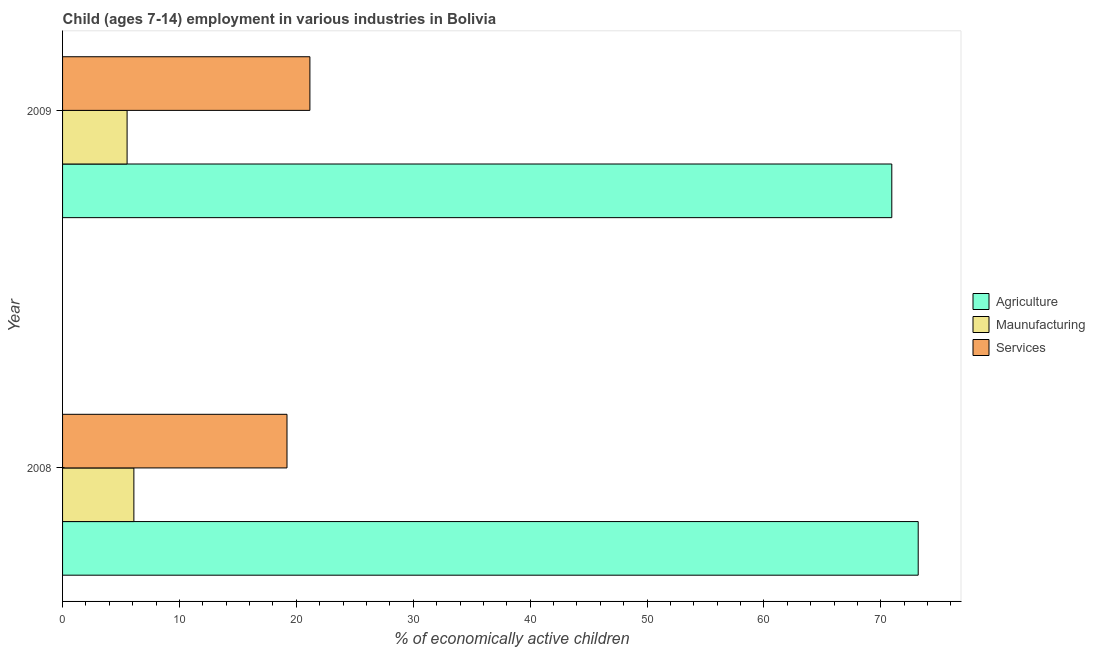How many different coloured bars are there?
Offer a very short reply. 3. How many groups of bars are there?
Your answer should be compact. 2. Are the number of bars per tick equal to the number of legend labels?
Keep it short and to the point. Yes. Are the number of bars on each tick of the Y-axis equal?
Ensure brevity in your answer.  Yes. How many bars are there on the 2nd tick from the top?
Offer a terse response. 3. What is the percentage of economically active children in agriculture in 2009?
Give a very brief answer. 70.94. Across all years, what is the maximum percentage of economically active children in manufacturing?
Keep it short and to the point. 6.1. Across all years, what is the minimum percentage of economically active children in services?
Make the answer very short. 19.2. In which year was the percentage of economically active children in agriculture maximum?
Make the answer very short. 2008. In which year was the percentage of economically active children in agriculture minimum?
Your answer should be very brief. 2009. What is the total percentage of economically active children in agriculture in the graph?
Ensure brevity in your answer.  144.14. What is the difference between the percentage of economically active children in agriculture in 2008 and that in 2009?
Offer a very short reply. 2.26. What is the difference between the percentage of economically active children in services in 2009 and the percentage of economically active children in manufacturing in 2008?
Provide a succinct answer. 15.06. What is the average percentage of economically active children in manufacturing per year?
Your answer should be very brief. 5.81. In the year 2008, what is the difference between the percentage of economically active children in agriculture and percentage of economically active children in services?
Your response must be concise. 54. In how many years, is the percentage of economically active children in manufacturing greater than 12 %?
Ensure brevity in your answer.  0. What is the ratio of the percentage of economically active children in services in 2008 to that in 2009?
Keep it short and to the point. 0.91. Is the difference between the percentage of economically active children in agriculture in 2008 and 2009 greater than the difference between the percentage of economically active children in services in 2008 and 2009?
Ensure brevity in your answer.  Yes. What does the 1st bar from the top in 2008 represents?
Provide a short and direct response. Services. What does the 2nd bar from the bottom in 2009 represents?
Provide a succinct answer. Maunufacturing. Is it the case that in every year, the sum of the percentage of economically active children in agriculture and percentage of economically active children in manufacturing is greater than the percentage of economically active children in services?
Your answer should be compact. Yes. How many bars are there?
Your answer should be compact. 6. Are all the bars in the graph horizontal?
Offer a terse response. Yes. How many years are there in the graph?
Your answer should be very brief. 2. Are the values on the major ticks of X-axis written in scientific E-notation?
Your response must be concise. No. Where does the legend appear in the graph?
Your response must be concise. Center right. What is the title of the graph?
Ensure brevity in your answer.  Child (ages 7-14) employment in various industries in Bolivia. What is the label or title of the X-axis?
Offer a very short reply. % of economically active children. What is the % of economically active children of Agriculture in 2008?
Offer a terse response. 73.2. What is the % of economically active children in Maunufacturing in 2008?
Ensure brevity in your answer.  6.1. What is the % of economically active children of Services in 2008?
Make the answer very short. 19.2. What is the % of economically active children in Agriculture in 2009?
Your answer should be compact. 70.94. What is the % of economically active children in Maunufacturing in 2009?
Offer a terse response. 5.52. What is the % of economically active children of Services in 2009?
Make the answer very short. 21.16. Across all years, what is the maximum % of economically active children in Agriculture?
Your response must be concise. 73.2. Across all years, what is the maximum % of economically active children of Services?
Ensure brevity in your answer.  21.16. Across all years, what is the minimum % of economically active children of Agriculture?
Make the answer very short. 70.94. Across all years, what is the minimum % of economically active children of Maunufacturing?
Offer a terse response. 5.52. Across all years, what is the minimum % of economically active children in Services?
Offer a terse response. 19.2. What is the total % of economically active children in Agriculture in the graph?
Provide a short and direct response. 144.14. What is the total % of economically active children of Maunufacturing in the graph?
Your response must be concise. 11.62. What is the total % of economically active children in Services in the graph?
Give a very brief answer. 40.36. What is the difference between the % of economically active children of Agriculture in 2008 and that in 2009?
Give a very brief answer. 2.26. What is the difference between the % of economically active children in Maunufacturing in 2008 and that in 2009?
Give a very brief answer. 0.58. What is the difference between the % of economically active children of Services in 2008 and that in 2009?
Provide a succinct answer. -1.96. What is the difference between the % of economically active children in Agriculture in 2008 and the % of economically active children in Maunufacturing in 2009?
Give a very brief answer. 67.68. What is the difference between the % of economically active children in Agriculture in 2008 and the % of economically active children in Services in 2009?
Offer a terse response. 52.04. What is the difference between the % of economically active children in Maunufacturing in 2008 and the % of economically active children in Services in 2009?
Give a very brief answer. -15.06. What is the average % of economically active children of Agriculture per year?
Keep it short and to the point. 72.07. What is the average % of economically active children of Maunufacturing per year?
Your answer should be very brief. 5.81. What is the average % of economically active children in Services per year?
Provide a succinct answer. 20.18. In the year 2008, what is the difference between the % of economically active children in Agriculture and % of economically active children in Maunufacturing?
Provide a short and direct response. 67.1. In the year 2008, what is the difference between the % of economically active children in Maunufacturing and % of economically active children in Services?
Offer a very short reply. -13.1. In the year 2009, what is the difference between the % of economically active children of Agriculture and % of economically active children of Maunufacturing?
Give a very brief answer. 65.42. In the year 2009, what is the difference between the % of economically active children in Agriculture and % of economically active children in Services?
Provide a succinct answer. 49.78. In the year 2009, what is the difference between the % of economically active children of Maunufacturing and % of economically active children of Services?
Make the answer very short. -15.64. What is the ratio of the % of economically active children in Agriculture in 2008 to that in 2009?
Keep it short and to the point. 1.03. What is the ratio of the % of economically active children of Maunufacturing in 2008 to that in 2009?
Your response must be concise. 1.11. What is the ratio of the % of economically active children in Services in 2008 to that in 2009?
Your answer should be very brief. 0.91. What is the difference between the highest and the second highest % of economically active children of Agriculture?
Provide a succinct answer. 2.26. What is the difference between the highest and the second highest % of economically active children of Maunufacturing?
Provide a short and direct response. 0.58. What is the difference between the highest and the second highest % of economically active children in Services?
Provide a succinct answer. 1.96. What is the difference between the highest and the lowest % of economically active children in Agriculture?
Offer a very short reply. 2.26. What is the difference between the highest and the lowest % of economically active children in Maunufacturing?
Offer a terse response. 0.58. What is the difference between the highest and the lowest % of economically active children in Services?
Make the answer very short. 1.96. 